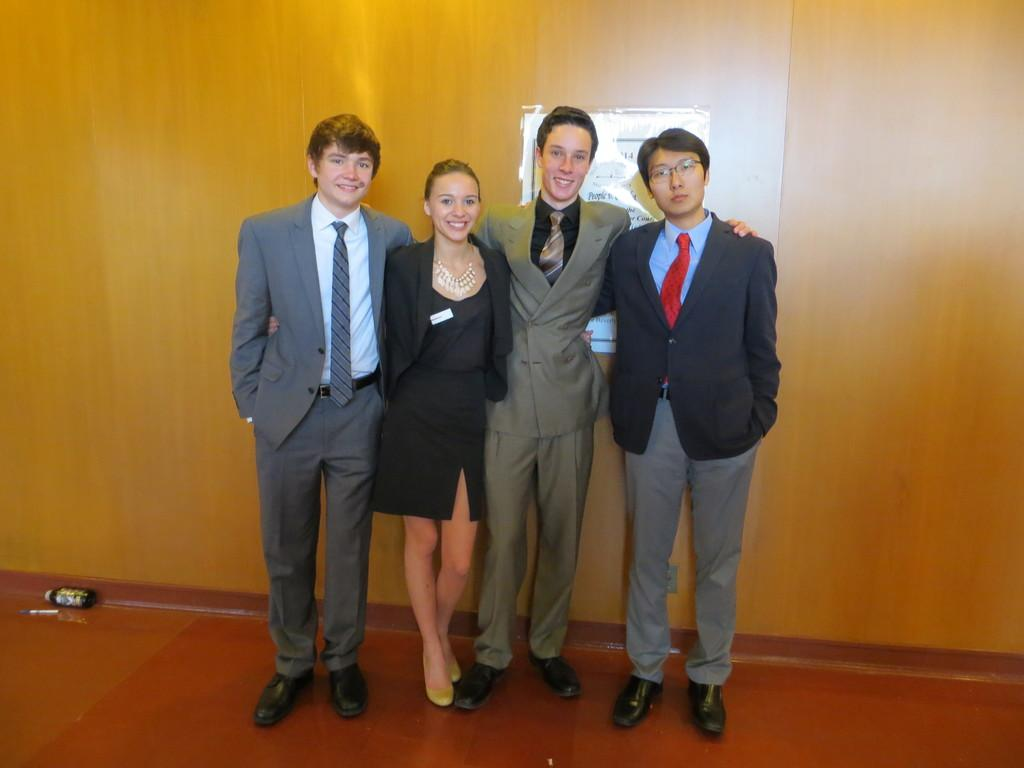What can be seen in the image? There are people standing in the image. What else is present in the image besides the people? There is a poster with text in the image. How are the men in the image dressed? The men in the image are wearing coats and ties. What type of mitten is being used to smash the poster in the image? There is no mitten or smashing action present in the image. The poster is simply hanging with text on it. 